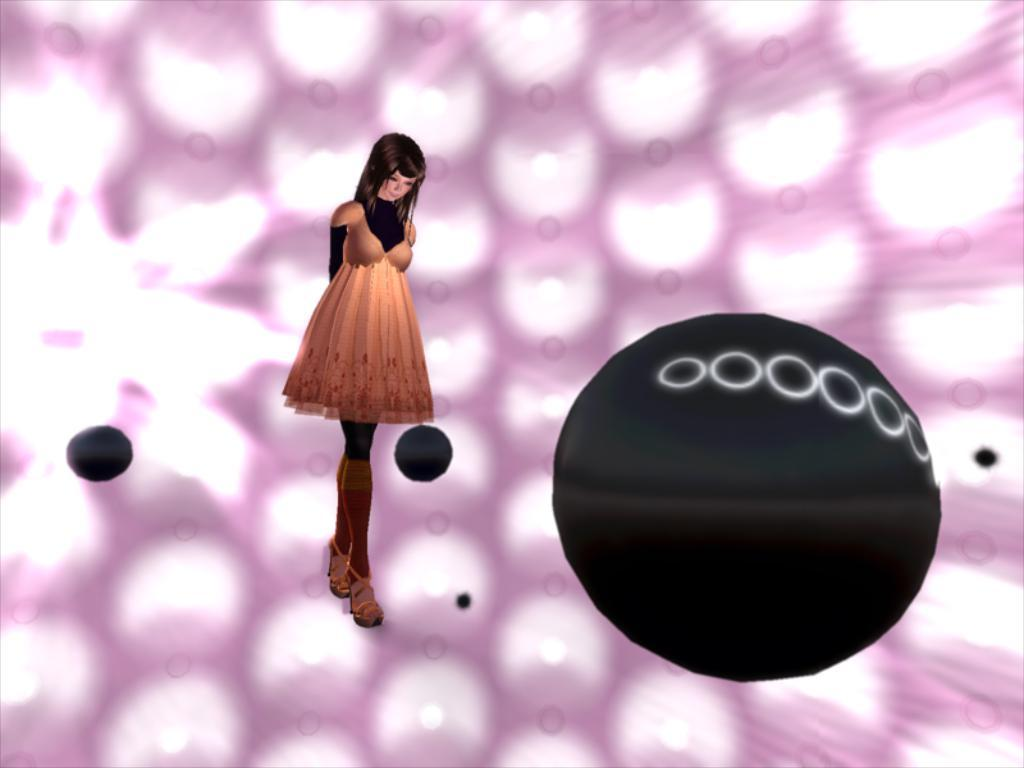What type of image is being described? The image appears to be a graphic. What colors are used for the background of the graphic? The background of the graphic is pink and white in color. What color are the objects in the graphic? The objects in the graphic are black in color. Can you describe the subject in the graphic? There is a girl standing in the graphic. What type of quiver can be seen in the graphic? There is no quiver present in the graphic; it features a girl standing in a pink and white background with black objects. 